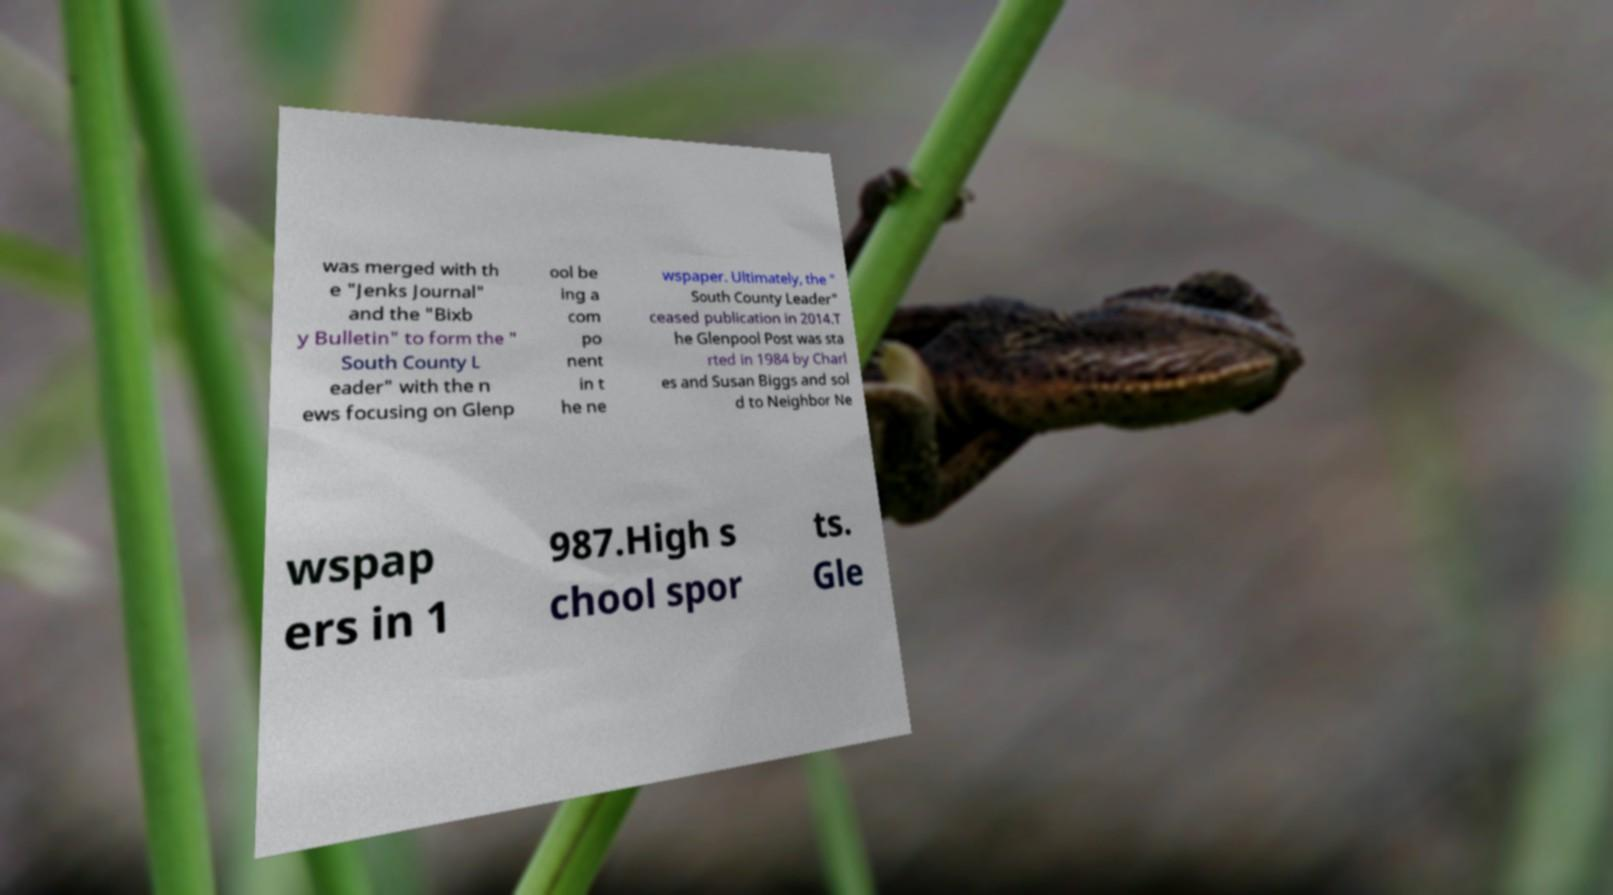Please identify and transcribe the text found in this image. was merged with th e "Jenks Journal" and the "Bixb y Bulletin" to form the " South County L eader" with the n ews focusing on Glenp ool be ing a com po nent in t he ne wspaper. Ultimately, the " South County Leader" ceased publication in 2014.T he Glenpool Post was sta rted in 1984 by Charl es and Susan Biggs and sol d to Neighbor Ne wspap ers in 1 987.High s chool spor ts. Gle 